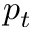<formula> <loc_0><loc_0><loc_500><loc_500>p _ { t }</formula> 